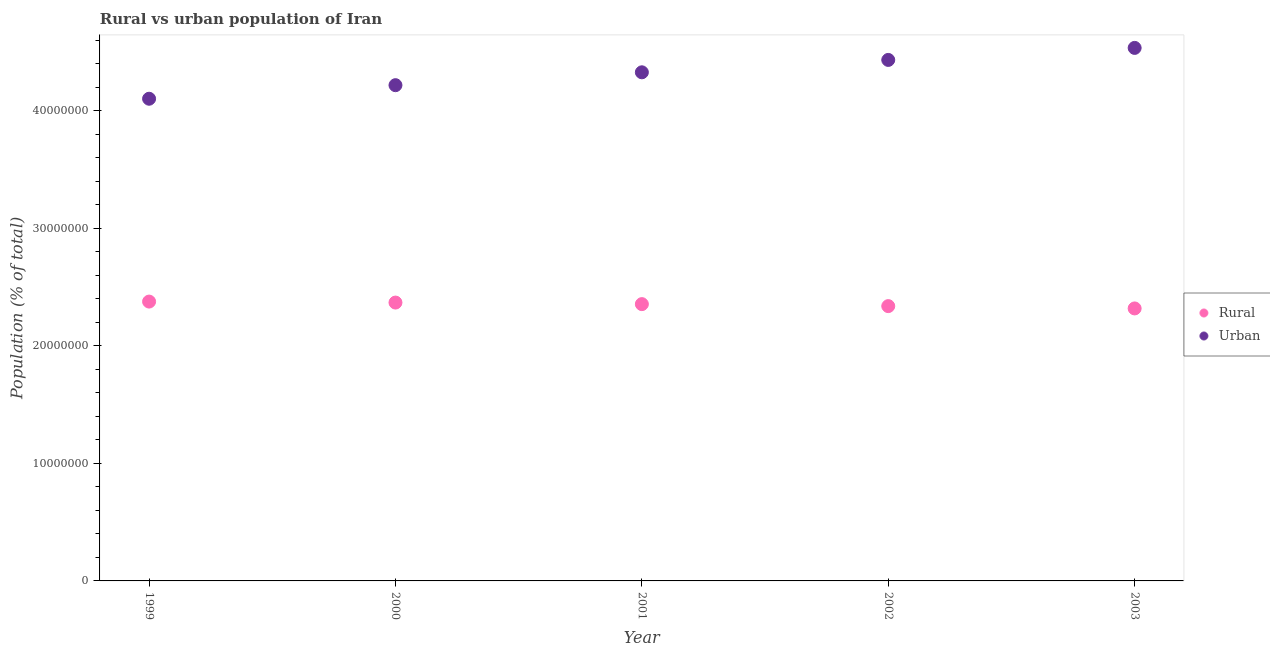What is the rural population density in 2003?
Your answer should be compact. 2.32e+07. Across all years, what is the maximum urban population density?
Make the answer very short. 4.53e+07. Across all years, what is the minimum urban population density?
Make the answer very short. 4.10e+07. In which year was the rural population density maximum?
Offer a terse response. 1999. In which year was the urban population density minimum?
Ensure brevity in your answer.  1999. What is the total urban population density in the graph?
Your response must be concise. 2.16e+08. What is the difference between the rural population density in 2001 and that in 2002?
Your answer should be compact. 1.69e+05. What is the difference between the rural population density in 2003 and the urban population density in 2001?
Offer a terse response. -2.01e+07. What is the average urban population density per year?
Make the answer very short. 4.32e+07. In the year 2003, what is the difference between the urban population density and rural population density?
Your response must be concise. 2.22e+07. What is the ratio of the rural population density in 1999 to that in 2002?
Make the answer very short. 1.02. Is the urban population density in 2000 less than that in 2001?
Provide a short and direct response. Yes. Is the difference between the urban population density in 1999 and 2000 greater than the difference between the rural population density in 1999 and 2000?
Ensure brevity in your answer.  No. What is the difference between the highest and the second highest rural population density?
Ensure brevity in your answer.  8.44e+04. What is the difference between the highest and the lowest rural population density?
Ensure brevity in your answer.  5.83e+05. Does the urban population density monotonically increase over the years?
Offer a terse response. Yes. Is the urban population density strictly less than the rural population density over the years?
Your answer should be compact. No. How many dotlines are there?
Provide a succinct answer. 2. What is the difference between two consecutive major ticks on the Y-axis?
Your answer should be compact. 1.00e+07. Are the values on the major ticks of Y-axis written in scientific E-notation?
Ensure brevity in your answer.  No. Does the graph contain any zero values?
Your answer should be compact. No. Does the graph contain grids?
Make the answer very short. No. Where does the legend appear in the graph?
Ensure brevity in your answer.  Center right. How many legend labels are there?
Provide a succinct answer. 2. What is the title of the graph?
Offer a very short reply. Rural vs urban population of Iran. What is the label or title of the X-axis?
Offer a very short reply. Year. What is the label or title of the Y-axis?
Keep it short and to the point. Population (% of total). What is the Population (% of total) of Rural in 1999?
Ensure brevity in your answer.  2.38e+07. What is the Population (% of total) in Urban in 1999?
Ensure brevity in your answer.  4.10e+07. What is the Population (% of total) of Rural in 2000?
Your response must be concise. 2.37e+07. What is the Population (% of total) in Urban in 2000?
Ensure brevity in your answer.  4.22e+07. What is the Population (% of total) in Rural in 2001?
Provide a succinct answer. 2.35e+07. What is the Population (% of total) of Urban in 2001?
Your answer should be compact. 4.33e+07. What is the Population (% of total) in Rural in 2002?
Your answer should be very brief. 2.34e+07. What is the Population (% of total) in Urban in 2002?
Your answer should be compact. 4.43e+07. What is the Population (% of total) of Rural in 2003?
Offer a very short reply. 2.32e+07. What is the Population (% of total) of Urban in 2003?
Your answer should be very brief. 4.53e+07. Across all years, what is the maximum Population (% of total) in Rural?
Offer a terse response. 2.38e+07. Across all years, what is the maximum Population (% of total) in Urban?
Provide a short and direct response. 4.53e+07. Across all years, what is the minimum Population (% of total) in Rural?
Your answer should be very brief. 2.32e+07. Across all years, what is the minimum Population (% of total) in Urban?
Give a very brief answer. 4.10e+07. What is the total Population (% of total) of Rural in the graph?
Your answer should be compact. 1.18e+08. What is the total Population (% of total) of Urban in the graph?
Your answer should be very brief. 2.16e+08. What is the difference between the Population (% of total) in Rural in 1999 and that in 2000?
Make the answer very short. 8.44e+04. What is the difference between the Population (% of total) of Urban in 1999 and that in 2000?
Offer a very short reply. -1.15e+06. What is the difference between the Population (% of total) of Rural in 1999 and that in 2001?
Make the answer very short. 2.17e+05. What is the difference between the Population (% of total) of Urban in 1999 and that in 2001?
Give a very brief answer. -2.25e+06. What is the difference between the Population (% of total) of Rural in 1999 and that in 2002?
Your answer should be very brief. 3.86e+05. What is the difference between the Population (% of total) in Urban in 1999 and that in 2002?
Make the answer very short. -3.30e+06. What is the difference between the Population (% of total) in Rural in 1999 and that in 2003?
Your answer should be very brief. 5.83e+05. What is the difference between the Population (% of total) in Urban in 1999 and that in 2003?
Make the answer very short. -4.32e+06. What is the difference between the Population (% of total) of Rural in 2000 and that in 2001?
Provide a short and direct response. 1.32e+05. What is the difference between the Population (% of total) in Urban in 2000 and that in 2001?
Your answer should be compact. -1.09e+06. What is the difference between the Population (% of total) of Rural in 2000 and that in 2002?
Provide a short and direct response. 3.01e+05. What is the difference between the Population (% of total) in Urban in 2000 and that in 2002?
Keep it short and to the point. -2.15e+06. What is the difference between the Population (% of total) of Rural in 2000 and that in 2003?
Offer a terse response. 4.99e+05. What is the difference between the Population (% of total) of Urban in 2000 and that in 2003?
Your response must be concise. -3.17e+06. What is the difference between the Population (% of total) in Rural in 2001 and that in 2002?
Give a very brief answer. 1.69e+05. What is the difference between the Population (% of total) of Urban in 2001 and that in 2002?
Give a very brief answer. -1.05e+06. What is the difference between the Population (% of total) in Rural in 2001 and that in 2003?
Provide a succinct answer. 3.66e+05. What is the difference between the Population (% of total) in Urban in 2001 and that in 2003?
Provide a short and direct response. -2.08e+06. What is the difference between the Population (% of total) of Rural in 2002 and that in 2003?
Your answer should be compact. 1.97e+05. What is the difference between the Population (% of total) of Urban in 2002 and that in 2003?
Ensure brevity in your answer.  -1.02e+06. What is the difference between the Population (% of total) of Rural in 1999 and the Population (% of total) of Urban in 2000?
Offer a terse response. -1.84e+07. What is the difference between the Population (% of total) of Rural in 1999 and the Population (% of total) of Urban in 2001?
Your answer should be very brief. -1.95e+07. What is the difference between the Population (% of total) of Rural in 1999 and the Population (% of total) of Urban in 2002?
Give a very brief answer. -2.06e+07. What is the difference between the Population (% of total) of Rural in 1999 and the Population (% of total) of Urban in 2003?
Offer a terse response. -2.16e+07. What is the difference between the Population (% of total) of Rural in 2000 and the Population (% of total) of Urban in 2001?
Keep it short and to the point. -1.96e+07. What is the difference between the Population (% of total) of Rural in 2000 and the Population (% of total) of Urban in 2002?
Provide a succinct answer. -2.06e+07. What is the difference between the Population (% of total) in Rural in 2000 and the Population (% of total) in Urban in 2003?
Give a very brief answer. -2.17e+07. What is the difference between the Population (% of total) of Rural in 2001 and the Population (% of total) of Urban in 2002?
Your answer should be compact. -2.08e+07. What is the difference between the Population (% of total) in Rural in 2001 and the Population (% of total) in Urban in 2003?
Your answer should be very brief. -2.18e+07. What is the difference between the Population (% of total) of Rural in 2002 and the Population (% of total) of Urban in 2003?
Keep it short and to the point. -2.20e+07. What is the average Population (% of total) of Rural per year?
Give a very brief answer. 2.35e+07. What is the average Population (% of total) of Urban per year?
Your answer should be compact. 4.32e+07. In the year 1999, what is the difference between the Population (% of total) of Rural and Population (% of total) of Urban?
Make the answer very short. -1.73e+07. In the year 2000, what is the difference between the Population (% of total) in Rural and Population (% of total) in Urban?
Your answer should be very brief. -1.85e+07. In the year 2001, what is the difference between the Population (% of total) in Rural and Population (% of total) in Urban?
Your answer should be very brief. -1.97e+07. In the year 2002, what is the difference between the Population (% of total) of Rural and Population (% of total) of Urban?
Ensure brevity in your answer.  -2.09e+07. In the year 2003, what is the difference between the Population (% of total) of Rural and Population (% of total) of Urban?
Give a very brief answer. -2.22e+07. What is the ratio of the Population (% of total) of Urban in 1999 to that in 2000?
Provide a short and direct response. 0.97. What is the ratio of the Population (% of total) of Rural in 1999 to that in 2001?
Your answer should be very brief. 1.01. What is the ratio of the Population (% of total) in Urban in 1999 to that in 2001?
Provide a short and direct response. 0.95. What is the ratio of the Population (% of total) in Rural in 1999 to that in 2002?
Provide a succinct answer. 1.02. What is the ratio of the Population (% of total) in Urban in 1999 to that in 2002?
Your response must be concise. 0.93. What is the ratio of the Population (% of total) of Rural in 1999 to that in 2003?
Make the answer very short. 1.03. What is the ratio of the Population (% of total) of Urban in 1999 to that in 2003?
Provide a succinct answer. 0.9. What is the ratio of the Population (% of total) in Rural in 2000 to that in 2001?
Offer a terse response. 1.01. What is the ratio of the Population (% of total) in Urban in 2000 to that in 2001?
Provide a short and direct response. 0.97. What is the ratio of the Population (% of total) in Rural in 2000 to that in 2002?
Provide a short and direct response. 1.01. What is the ratio of the Population (% of total) of Urban in 2000 to that in 2002?
Provide a succinct answer. 0.95. What is the ratio of the Population (% of total) of Rural in 2000 to that in 2003?
Give a very brief answer. 1.02. What is the ratio of the Population (% of total) of Urban in 2000 to that in 2003?
Keep it short and to the point. 0.93. What is the ratio of the Population (% of total) of Urban in 2001 to that in 2002?
Keep it short and to the point. 0.98. What is the ratio of the Population (% of total) of Rural in 2001 to that in 2003?
Provide a short and direct response. 1.02. What is the ratio of the Population (% of total) of Urban in 2001 to that in 2003?
Your answer should be compact. 0.95. What is the ratio of the Population (% of total) in Rural in 2002 to that in 2003?
Ensure brevity in your answer.  1.01. What is the ratio of the Population (% of total) in Urban in 2002 to that in 2003?
Offer a terse response. 0.98. What is the difference between the highest and the second highest Population (% of total) in Rural?
Offer a very short reply. 8.44e+04. What is the difference between the highest and the second highest Population (% of total) of Urban?
Provide a short and direct response. 1.02e+06. What is the difference between the highest and the lowest Population (% of total) of Rural?
Your answer should be compact. 5.83e+05. What is the difference between the highest and the lowest Population (% of total) in Urban?
Provide a short and direct response. 4.32e+06. 